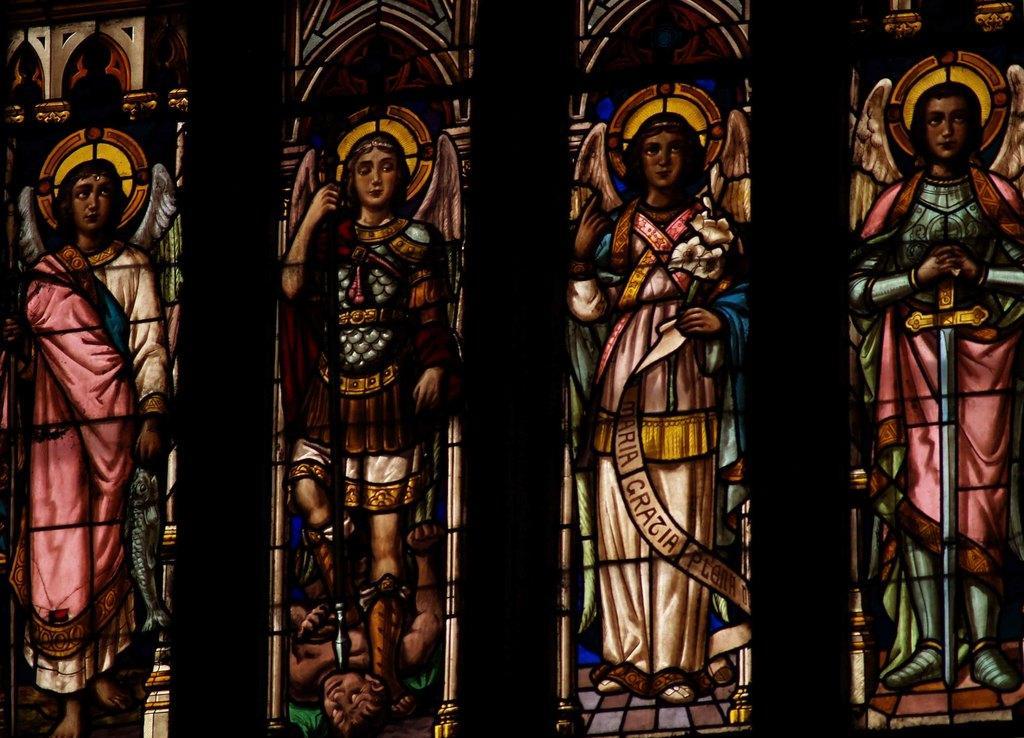In one or two sentences, can you explain what this image depicts? In this image we can see the painting of a person and objects on the glasses. 